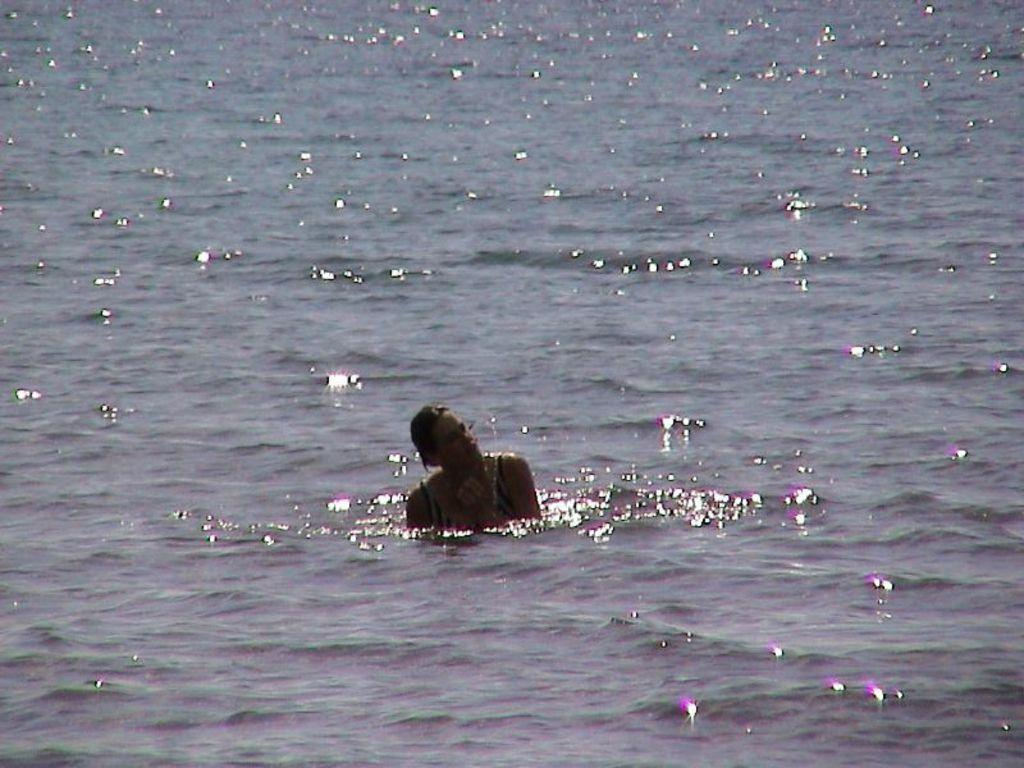What is the main subject in the foreground of the picture? There is a woman in the foreground of the picture. Where is the woman located in the image? The woman is in the water. What type of fork can be seen in the woman's hand in the image? There is no fork present in the image; the woman is in the water. Does the woman have a tail in the image? There is no tail visible on the woman in the image. 